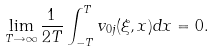Convert formula to latex. <formula><loc_0><loc_0><loc_500><loc_500>\lim _ { T \rightarrow \infty } \frac { 1 } { 2 T } \int _ { - T } ^ { T } v _ { 0 j } ( \xi , x ) d x = 0 .</formula> 